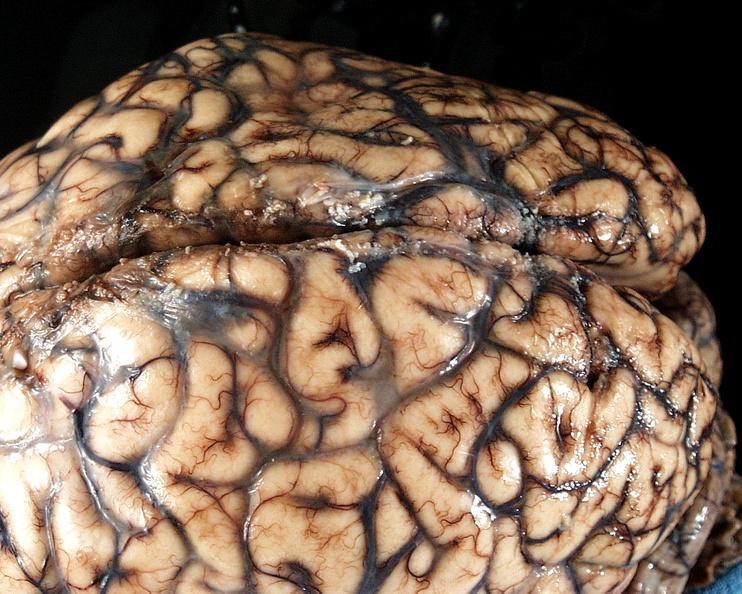what does this image show?
Answer the question using a single word or phrase. Brain 